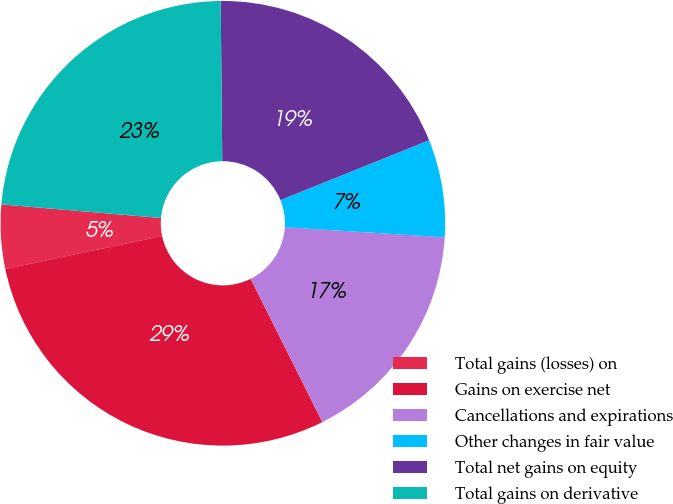Convert chart. <chart><loc_0><loc_0><loc_500><loc_500><pie_chart><fcel>Total gains (losses) on<fcel>Gains on exercise net<fcel>Cancellations and expirations<fcel>Other changes in fair value<fcel>Total net gains on equity<fcel>Total gains on derivative<nl><fcel>4.65%<fcel>29.09%<fcel>16.61%<fcel>7.1%<fcel>19.06%<fcel>23.49%<nl></chart> 